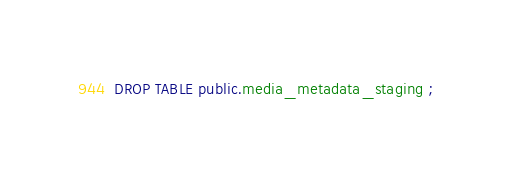Convert code to text. <code><loc_0><loc_0><loc_500><loc_500><_SQL_>DROP TABLE public.media_metadata_staging ;
</code> 